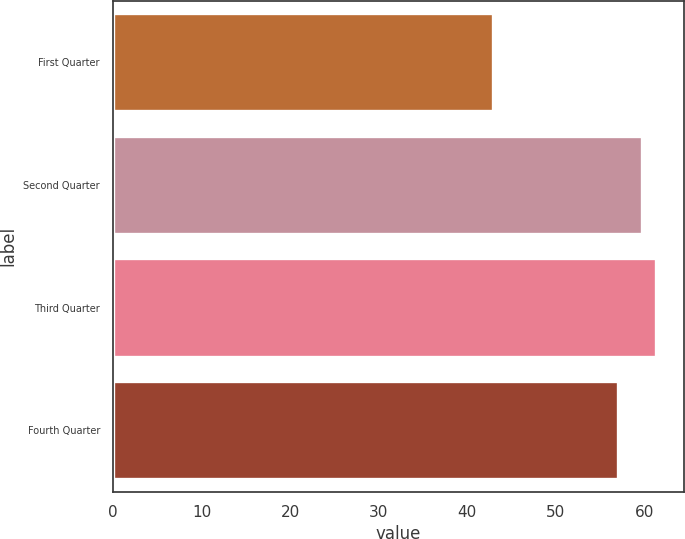Convert chart to OTSL. <chart><loc_0><loc_0><loc_500><loc_500><bar_chart><fcel>First Quarter<fcel>Second Quarter<fcel>Third Quarter<fcel>Fourth Quarter<nl><fcel>42.94<fcel>59.68<fcel>61.36<fcel>57<nl></chart> 